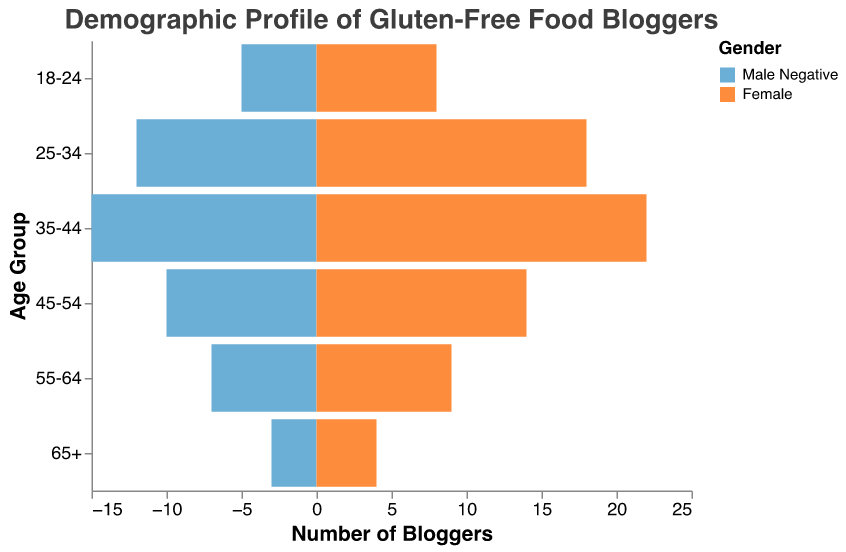What is the total number of 18-24-year-old female bloggers? Look at the bar representing the 18-24 age group on the female side. The value shown is 8.
Answer: 8 How many more 35-44-year-old female bloggers are there compared to male bloggers in the same age group? The value for 35-44-year-old female bloggers is 22 and for males, it is 15. The difference is 22 - 15.
Answer: 7 Which age group has the highest number of bloggers overall? Sum the number of male and female bloggers for each age group. 18-24: 5+8, 25-34: 12+18, 35-44: 15+22, 45-54: 10+14, 55-64: 7+9, 65+: 3+4. The group with the highest sum is 35-44.
Answer: 35-44 What is the average number of bloggers in the 55-64 age group? Sum the male and female bloggers in the 55-64 age group, then divide by 2. (7 + 9) / 2 = 8
Answer: 8 How does the gender distribution vary for 45-54-year-olds? Compare the bars for males and females in the 45-54 age group. There are 10 males and 14 females, showing that there are more females than males in this age group.
Answer: More females Which gender has the highest number of bloggers in the 25-34 age group? Look at the values for males and females in the 25-34 age group. The number of female bloggers (18) is higher than the number of male bloggers (12).
Answer: Female What is the total number of female bloggers across all age groups? Sum the number of female bloggers in each age group: 8 + 18 + 22 + 14 + 9 + 4 = 75.
Answer: 75 By how much does the number of 35-44 male bloggers exceed that of 65+ male bloggers? The number of 35-44 male bloggers is 15, and the number of 65+ male bloggers is 3. The difference is 15 - 3.
Answer: 12 In which age group is the gender disparity (absolute difference between males and females) the greatest? Calculate the absolute difference between males and females for each age group: 18-24: 3, 25-34: 6, 35-44: 7, 45-54: 4, 55-64: 2, 65+: 1. The greatest disparity is in the 35-44 age group.
Answer: 35-44 Is there any age group with an equal number of male and female bloggers? Compare the numbers for males and females in each age group. None of the age groups have an equal number of male and female bloggers.
Answer: No 